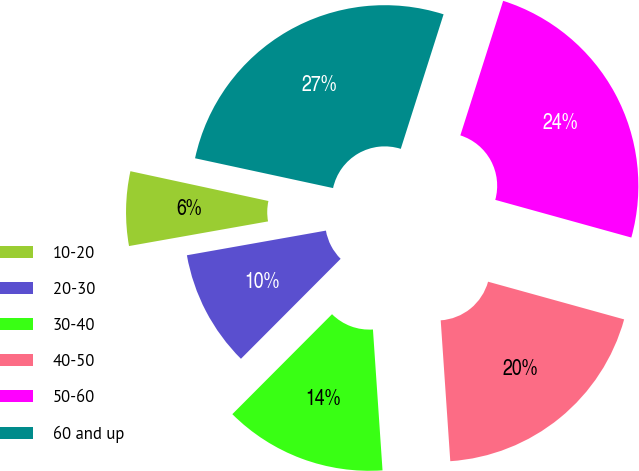Convert chart to OTSL. <chart><loc_0><loc_0><loc_500><loc_500><pie_chart><fcel>10-20<fcel>20-30<fcel>30-40<fcel>40-50<fcel>50-60<fcel>60 and up<nl><fcel>6.18%<fcel>9.73%<fcel>13.56%<fcel>19.62%<fcel>24.4%<fcel>26.52%<nl></chart> 